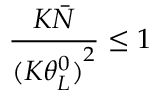<formula> <loc_0><loc_0><loc_500><loc_500>\frac { { K \bar { N } } } { ( K { { \theta _ { L } ^ { 0 } ) } ^ { 2 } } } \leq 1</formula> 